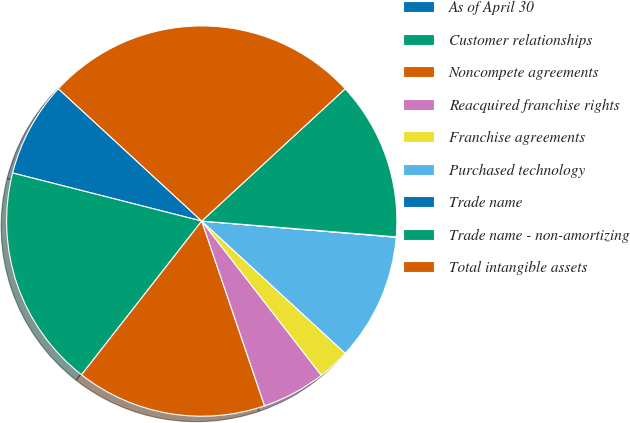Convert chart to OTSL. <chart><loc_0><loc_0><loc_500><loc_500><pie_chart><fcel>As of April 30<fcel>Customer relationships<fcel>Noncompete agreements<fcel>Reacquired franchise rights<fcel>Franchise agreements<fcel>Purchased technology<fcel>Trade name<fcel>Trade name - non-amortizing<fcel>Total intangible assets<nl><fcel>7.9%<fcel>18.4%<fcel>15.78%<fcel>5.28%<fcel>2.65%<fcel>10.53%<fcel>0.03%<fcel>13.15%<fcel>26.28%<nl></chart> 